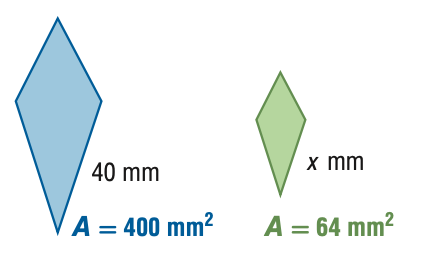Question: For the pair of similar figures, use the given areas to find the scale factor of the blue to the green figure.
Choices:
A. \frac { 4 } { 25 }
B. \frac { 2 } { 5 }
C. \frac { 5 } { 2 }
D. \frac { 25 } { 4 }
Answer with the letter. Answer: C 